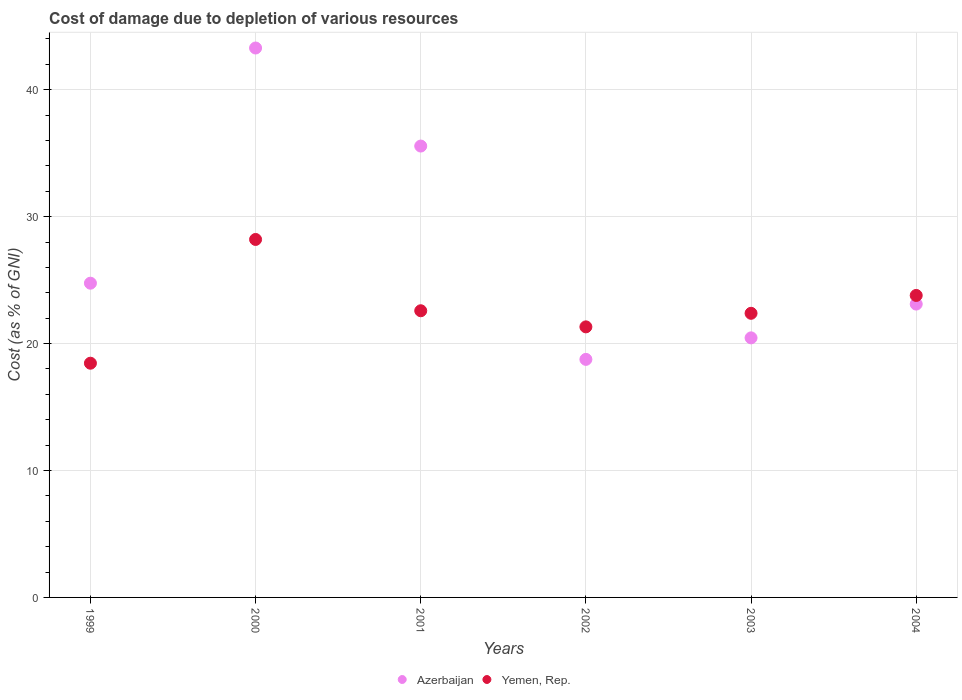How many different coloured dotlines are there?
Your answer should be very brief. 2. What is the cost of damage caused due to the depletion of various resources in Yemen, Rep. in 1999?
Provide a short and direct response. 18.45. Across all years, what is the maximum cost of damage caused due to the depletion of various resources in Yemen, Rep.?
Offer a terse response. 28.2. Across all years, what is the minimum cost of damage caused due to the depletion of various resources in Yemen, Rep.?
Your answer should be compact. 18.45. In which year was the cost of damage caused due to the depletion of various resources in Azerbaijan minimum?
Provide a succinct answer. 2002. What is the total cost of damage caused due to the depletion of various resources in Azerbaijan in the graph?
Offer a terse response. 165.91. What is the difference between the cost of damage caused due to the depletion of various resources in Yemen, Rep. in 2000 and that in 2003?
Make the answer very short. 5.82. What is the difference between the cost of damage caused due to the depletion of various resources in Yemen, Rep. in 2002 and the cost of damage caused due to the depletion of various resources in Azerbaijan in 2000?
Ensure brevity in your answer.  -21.97. What is the average cost of damage caused due to the depletion of various resources in Yemen, Rep. per year?
Provide a succinct answer. 22.79. In the year 2004, what is the difference between the cost of damage caused due to the depletion of various resources in Azerbaijan and cost of damage caused due to the depletion of various resources in Yemen, Rep.?
Your answer should be very brief. -0.68. What is the ratio of the cost of damage caused due to the depletion of various resources in Yemen, Rep. in 1999 to that in 2002?
Provide a succinct answer. 0.87. Is the cost of damage caused due to the depletion of various resources in Azerbaijan in 2000 less than that in 2002?
Offer a very short reply. No. What is the difference between the highest and the second highest cost of damage caused due to the depletion of various resources in Yemen, Rep.?
Ensure brevity in your answer.  4.41. What is the difference between the highest and the lowest cost of damage caused due to the depletion of various resources in Yemen, Rep.?
Your answer should be very brief. 9.75. In how many years, is the cost of damage caused due to the depletion of various resources in Azerbaijan greater than the average cost of damage caused due to the depletion of various resources in Azerbaijan taken over all years?
Ensure brevity in your answer.  2. Is the sum of the cost of damage caused due to the depletion of various resources in Yemen, Rep. in 2001 and 2002 greater than the maximum cost of damage caused due to the depletion of various resources in Azerbaijan across all years?
Provide a succinct answer. Yes. How many dotlines are there?
Provide a succinct answer. 2. How many years are there in the graph?
Offer a terse response. 6. What is the difference between two consecutive major ticks on the Y-axis?
Your answer should be very brief. 10. Are the values on the major ticks of Y-axis written in scientific E-notation?
Your response must be concise. No. Does the graph contain any zero values?
Offer a terse response. No. Where does the legend appear in the graph?
Your answer should be very brief. Bottom center. How many legend labels are there?
Give a very brief answer. 2. What is the title of the graph?
Give a very brief answer. Cost of damage due to depletion of various resources. What is the label or title of the X-axis?
Give a very brief answer. Years. What is the label or title of the Y-axis?
Your response must be concise. Cost (as % of GNI). What is the Cost (as % of GNI) of Azerbaijan in 1999?
Your answer should be compact. 24.76. What is the Cost (as % of GNI) of Yemen, Rep. in 1999?
Offer a very short reply. 18.45. What is the Cost (as % of GNI) in Azerbaijan in 2000?
Your response must be concise. 43.28. What is the Cost (as % of GNI) of Yemen, Rep. in 2000?
Keep it short and to the point. 28.2. What is the Cost (as % of GNI) in Azerbaijan in 2001?
Your answer should be very brief. 35.56. What is the Cost (as % of GNI) in Yemen, Rep. in 2001?
Your answer should be very brief. 22.58. What is the Cost (as % of GNI) in Azerbaijan in 2002?
Keep it short and to the point. 18.75. What is the Cost (as % of GNI) in Yemen, Rep. in 2002?
Keep it short and to the point. 21.31. What is the Cost (as % of GNI) of Azerbaijan in 2003?
Offer a very short reply. 20.45. What is the Cost (as % of GNI) in Yemen, Rep. in 2003?
Provide a short and direct response. 22.38. What is the Cost (as % of GNI) in Azerbaijan in 2004?
Give a very brief answer. 23.11. What is the Cost (as % of GNI) of Yemen, Rep. in 2004?
Make the answer very short. 23.79. Across all years, what is the maximum Cost (as % of GNI) of Azerbaijan?
Your response must be concise. 43.28. Across all years, what is the maximum Cost (as % of GNI) of Yemen, Rep.?
Give a very brief answer. 28.2. Across all years, what is the minimum Cost (as % of GNI) in Azerbaijan?
Give a very brief answer. 18.75. Across all years, what is the minimum Cost (as % of GNI) of Yemen, Rep.?
Your answer should be very brief. 18.45. What is the total Cost (as % of GNI) in Azerbaijan in the graph?
Ensure brevity in your answer.  165.91. What is the total Cost (as % of GNI) in Yemen, Rep. in the graph?
Offer a very short reply. 136.73. What is the difference between the Cost (as % of GNI) of Azerbaijan in 1999 and that in 2000?
Ensure brevity in your answer.  -18.53. What is the difference between the Cost (as % of GNI) of Yemen, Rep. in 1999 and that in 2000?
Keep it short and to the point. -9.75. What is the difference between the Cost (as % of GNI) in Azerbaijan in 1999 and that in 2001?
Your response must be concise. -10.8. What is the difference between the Cost (as % of GNI) of Yemen, Rep. in 1999 and that in 2001?
Your response must be concise. -4.13. What is the difference between the Cost (as % of GNI) of Azerbaijan in 1999 and that in 2002?
Provide a succinct answer. 6. What is the difference between the Cost (as % of GNI) of Yemen, Rep. in 1999 and that in 2002?
Your response must be concise. -2.86. What is the difference between the Cost (as % of GNI) in Azerbaijan in 1999 and that in 2003?
Make the answer very short. 4.31. What is the difference between the Cost (as % of GNI) of Yemen, Rep. in 1999 and that in 2003?
Your answer should be compact. -3.93. What is the difference between the Cost (as % of GNI) in Azerbaijan in 1999 and that in 2004?
Give a very brief answer. 1.65. What is the difference between the Cost (as % of GNI) of Yemen, Rep. in 1999 and that in 2004?
Ensure brevity in your answer.  -5.34. What is the difference between the Cost (as % of GNI) in Azerbaijan in 2000 and that in 2001?
Provide a short and direct response. 7.72. What is the difference between the Cost (as % of GNI) of Yemen, Rep. in 2000 and that in 2001?
Give a very brief answer. 5.62. What is the difference between the Cost (as % of GNI) in Azerbaijan in 2000 and that in 2002?
Make the answer very short. 24.53. What is the difference between the Cost (as % of GNI) of Yemen, Rep. in 2000 and that in 2002?
Offer a very short reply. 6.89. What is the difference between the Cost (as % of GNI) of Azerbaijan in 2000 and that in 2003?
Keep it short and to the point. 22.83. What is the difference between the Cost (as % of GNI) of Yemen, Rep. in 2000 and that in 2003?
Offer a terse response. 5.82. What is the difference between the Cost (as % of GNI) of Azerbaijan in 2000 and that in 2004?
Your answer should be compact. 20.17. What is the difference between the Cost (as % of GNI) in Yemen, Rep. in 2000 and that in 2004?
Offer a terse response. 4.41. What is the difference between the Cost (as % of GNI) of Azerbaijan in 2001 and that in 2002?
Ensure brevity in your answer.  16.81. What is the difference between the Cost (as % of GNI) of Yemen, Rep. in 2001 and that in 2002?
Give a very brief answer. 1.27. What is the difference between the Cost (as % of GNI) in Azerbaijan in 2001 and that in 2003?
Offer a very short reply. 15.11. What is the difference between the Cost (as % of GNI) in Yemen, Rep. in 2001 and that in 2003?
Offer a very short reply. 0.2. What is the difference between the Cost (as % of GNI) in Azerbaijan in 2001 and that in 2004?
Your answer should be compact. 12.45. What is the difference between the Cost (as % of GNI) of Yemen, Rep. in 2001 and that in 2004?
Your response must be concise. -1.21. What is the difference between the Cost (as % of GNI) in Azerbaijan in 2002 and that in 2003?
Make the answer very short. -1.7. What is the difference between the Cost (as % of GNI) of Yemen, Rep. in 2002 and that in 2003?
Provide a succinct answer. -1.07. What is the difference between the Cost (as % of GNI) in Azerbaijan in 2002 and that in 2004?
Offer a very short reply. -4.36. What is the difference between the Cost (as % of GNI) in Yemen, Rep. in 2002 and that in 2004?
Make the answer very short. -2.48. What is the difference between the Cost (as % of GNI) of Azerbaijan in 2003 and that in 2004?
Keep it short and to the point. -2.66. What is the difference between the Cost (as % of GNI) in Yemen, Rep. in 2003 and that in 2004?
Provide a succinct answer. -1.41. What is the difference between the Cost (as % of GNI) in Azerbaijan in 1999 and the Cost (as % of GNI) in Yemen, Rep. in 2000?
Ensure brevity in your answer.  -3.45. What is the difference between the Cost (as % of GNI) of Azerbaijan in 1999 and the Cost (as % of GNI) of Yemen, Rep. in 2001?
Offer a very short reply. 2.17. What is the difference between the Cost (as % of GNI) of Azerbaijan in 1999 and the Cost (as % of GNI) of Yemen, Rep. in 2002?
Offer a very short reply. 3.44. What is the difference between the Cost (as % of GNI) of Azerbaijan in 1999 and the Cost (as % of GNI) of Yemen, Rep. in 2003?
Provide a short and direct response. 2.37. What is the difference between the Cost (as % of GNI) of Azerbaijan in 1999 and the Cost (as % of GNI) of Yemen, Rep. in 2004?
Provide a short and direct response. 0.97. What is the difference between the Cost (as % of GNI) in Azerbaijan in 2000 and the Cost (as % of GNI) in Yemen, Rep. in 2001?
Provide a succinct answer. 20.7. What is the difference between the Cost (as % of GNI) of Azerbaijan in 2000 and the Cost (as % of GNI) of Yemen, Rep. in 2002?
Make the answer very short. 21.97. What is the difference between the Cost (as % of GNI) in Azerbaijan in 2000 and the Cost (as % of GNI) in Yemen, Rep. in 2003?
Your answer should be compact. 20.9. What is the difference between the Cost (as % of GNI) of Azerbaijan in 2000 and the Cost (as % of GNI) of Yemen, Rep. in 2004?
Your answer should be compact. 19.49. What is the difference between the Cost (as % of GNI) of Azerbaijan in 2001 and the Cost (as % of GNI) of Yemen, Rep. in 2002?
Keep it short and to the point. 14.24. What is the difference between the Cost (as % of GNI) in Azerbaijan in 2001 and the Cost (as % of GNI) in Yemen, Rep. in 2003?
Make the answer very short. 13.18. What is the difference between the Cost (as % of GNI) in Azerbaijan in 2001 and the Cost (as % of GNI) in Yemen, Rep. in 2004?
Give a very brief answer. 11.77. What is the difference between the Cost (as % of GNI) in Azerbaijan in 2002 and the Cost (as % of GNI) in Yemen, Rep. in 2003?
Your answer should be compact. -3.63. What is the difference between the Cost (as % of GNI) in Azerbaijan in 2002 and the Cost (as % of GNI) in Yemen, Rep. in 2004?
Give a very brief answer. -5.04. What is the difference between the Cost (as % of GNI) in Azerbaijan in 2003 and the Cost (as % of GNI) in Yemen, Rep. in 2004?
Make the answer very short. -3.34. What is the average Cost (as % of GNI) in Azerbaijan per year?
Provide a short and direct response. 27.65. What is the average Cost (as % of GNI) in Yemen, Rep. per year?
Your answer should be very brief. 22.79. In the year 1999, what is the difference between the Cost (as % of GNI) in Azerbaijan and Cost (as % of GNI) in Yemen, Rep.?
Ensure brevity in your answer.  6.3. In the year 2000, what is the difference between the Cost (as % of GNI) of Azerbaijan and Cost (as % of GNI) of Yemen, Rep.?
Give a very brief answer. 15.08. In the year 2001, what is the difference between the Cost (as % of GNI) of Azerbaijan and Cost (as % of GNI) of Yemen, Rep.?
Provide a short and direct response. 12.97. In the year 2002, what is the difference between the Cost (as % of GNI) of Azerbaijan and Cost (as % of GNI) of Yemen, Rep.?
Your answer should be compact. -2.56. In the year 2003, what is the difference between the Cost (as % of GNI) in Azerbaijan and Cost (as % of GNI) in Yemen, Rep.?
Provide a succinct answer. -1.93. In the year 2004, what is the difference between the Cost (as % of GNI) of Azerbaijan and Cost (as % of GNI) of Yemen, Rep.?
Provide a succinct answer. -0.68. What is the ratio of the Cost (as % of GNI) of Azerbaijan in 1999 to that in 2000?
Your answer should be very brief. 0.57. What is the ratio of the Cost (as % of GNI) in Yemen, Rep. in 1999 to that in 2000?
Your answer should be very brief. 0.65. What is the ratio of the Cost (as % of GNI) of Azerbaijan in 1999 to that in 2001?
Make the answer very short. 0.7. What is the ratio of the Cost (as % of GNI) in Yemen, Rep. in 1999 to that in 2001?
Offer a terse response. 0.82. What is the ratio of the Cost (as % of GNI) of Azerbaijan in 1999 to that in 2002?
Provide a succinct answer. 1.32. What is the ratio of the Cost (as % of GNI) of Yemen, Rep. in 1999 to that in 2002?
Keep it short and to the point. 0.87. What is the ratio of the Cost (as % of GNI) in Azerbaijan in 1999 to that in 2003?
Your answer should be compact. 1.21. What is the ratio of the Cost (as % of GNI) of Yemen, Rep. in 1999 to that in 2003?
Your answer should be compact. 0.82. What is the ratio of the Cost (as % of GNI) of Azerbaijan in 1999 to that in 2004?
Offer a terse response. 1.07. What is the ratio of the Cost (as % of GNI) of Yemen, Rep. in 1999 to that in 2004?
Your response must be concise. 0.78. What is the ratio of the Cost (as % of GNI) of Azerbaijan in 2000 to that in 2001?
Ensure brevity in your answer.  1.22. What is the ratio of the Cost (as % of GNI) of Yemen, Rep. in 2000 to that in 2001?
Your answer should be compact. 1.25. What is the ratio of the Cost (as % of GNI) of Azerbaijan in 2000 to that in 2002?
Provide a short and direct response. 2.31. What is the ratio of the Cost (as % of GNI) of Yemen, Rep. in 2000 to that in 2002?
Provide a short and direct response. 1.32. What is the ratio of the Cost (as % of GNI) in Azerbaijan in 2000 to that in 2003?
Give a very brief answer. 2.12. What is the ratio of the Cost (as % of GNI) in Yemen, Rep. in 2000 to that in 2003?
Make the answer very short. 1.26. What is the ratio of the Cost (as % of GNI) of Azerbaijan in 2000 to that in 2004?
Offer a terse response. 1.87. What is the ratio of the Cost (as % of GNI) of Yemen, Rep. in 2000 to that in 2004?
Provide a succinct answer. 1.19. What is the ratio of the Cost (as % of GNI) in Azerbaijan in 2001 to that in 2002?
Your response must be concise. 1.9. What is the ratio of the Cost (as % of GNI) of Yemen, Rep. in 2001 to that in 2002?
Provide a short and direct response. 1.06. What is the ratio of the Cost (as % of GNI) of Azerbaijan in 2001 to that in 2003?
Provide a succinct answer. 1.74. What is the ratio of the Cost (as % of GNI) of Yemen, Rep. in 2001 to that in 2003?
Your answer should be compact. 1.01. What is the ratio of the Cost (as % of GNI) of Azerbaijan in 2001 to that in 2004?
Your answer should be very brief. 1.54. What is the ratio of the Cost (as % of GNI) of Yemen, Rep. in 2001 to that in 2004?
Your answer should be compact. 0.95. What is the ratio of the Cost (as % of GNI) in Azerbaijan in 2002 to that in 2003?
Give a very brief answer. 0.92. What is the ratio of the Cost (as % of GNI) in Yemen, Rep. in 2002 to that in 2003?
Your answer should be compact. 0.95. What is the ratio of the Cost (as % of GNI) in Azerbaijan in 2002 to that in 2004?
Your answer should be compact. 0.81. What is the ratio of the Cost (as % of GNI) in Yemen, Rep. in 2002 to that in 2004?
Make the answer very short. 0.9. What is the ratio of the Cost (as % of GNI) of Azerbaijan in 2003 to that in 2004?
Make the answer very short. 0.88. What is the ratio of the Cost (as % of GNI) in Yemen, Rep. in 2003 to that in 2004?
Give a very brief answer. 0.94. What is the difference between the highest and the second highest Cost (as % of GNI) of Azerbaijan?
Make the answer very short. 7.72. What is the difference between the highest and the second highest Cost (as % of GNI) in Yemen, Rep.?
Ensure brevity in your answer.  4.41. What is the difference between the highest and the lowest Cost (as % of GNI) of Azerbaijan?
Provide a succinct answer. 24.53. What is the difference between the highest and the lowest Cost (as % of GNI) of Yemen, Rep.?
Make the answer very short. 9.75. 